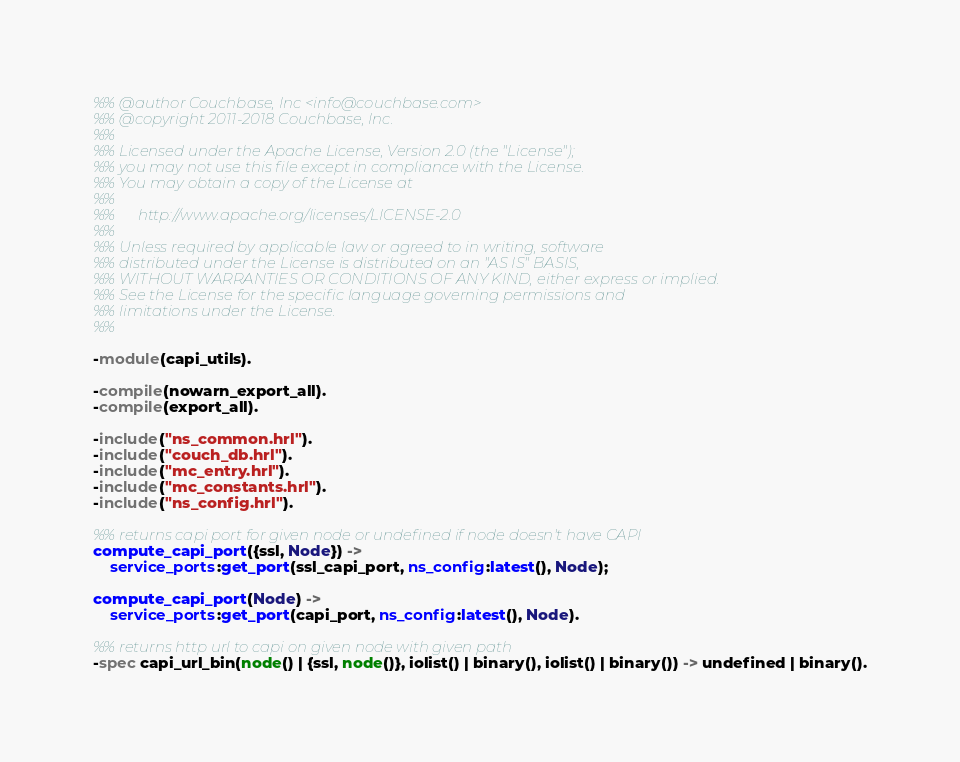<code> <loc_0><loc_0><loc_500><loc_500><_Erlang_>%% @author Couchbase, Inc <info@couchbase.com>
%% @copyright 2011-2018 Couchbase, Inc.
%%
%% Licensed under the Apache License, Version 2.0 (the "License");
%% you may not use this file except in compliance with the License.
%% You may obtain a copy of the License at
%%
%%      http://www.apache.org/licenses/LICENSE-2.0
%%
%% Unless required by applicable law or agreed to in writing, software
%% distributed under the License is distributed on an "AS IS" BASIS,
%% WITHOUT WARRANTIES OR CONDITIONS OF ANY KIND, either express or implied.
%% See the License for the specific language governing permissions and
%% limitations under the License.
%%

-module(capi_utils).

-compile(nowarn_export_all).
-compile(export_all).

-include("ns_common.hrl").
-include("couch_db.hrl").
-include("mc_entry.hrl").
-include("mc_constants.hrl").
-include("ns_config.hrl").

%% returns capi port for given node or undefined if node doesn't have CAPI
compute_capi_port({ssl, Node}) ->
    service_ports:get_port(ssl_capi_port, ns_config:latest(), Node);

compute_capi_port(Node) ->
    service_ports:get_port(capi_port, ns_config:latest(), Node).

%% returns http url to capi on given node with given path
-spec capi_url_bin(node() | {ssl, node()}, iolist() | binary(), iolist() | binary()) -> undefined | binary().</code> 